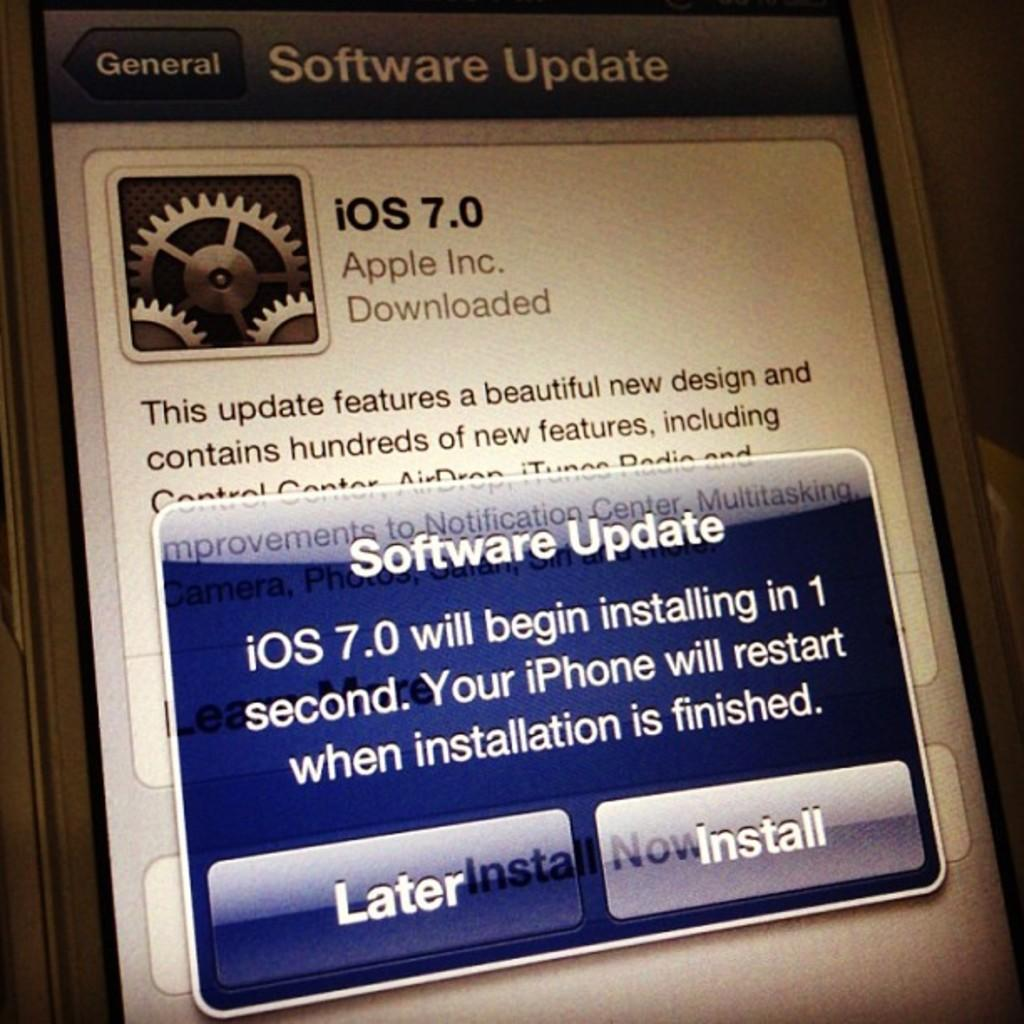<image>
Present a compact description of the photo's key features. The screen of an iphone shows the software update for iOS 7.0 has been downloaded and is ready to install. 